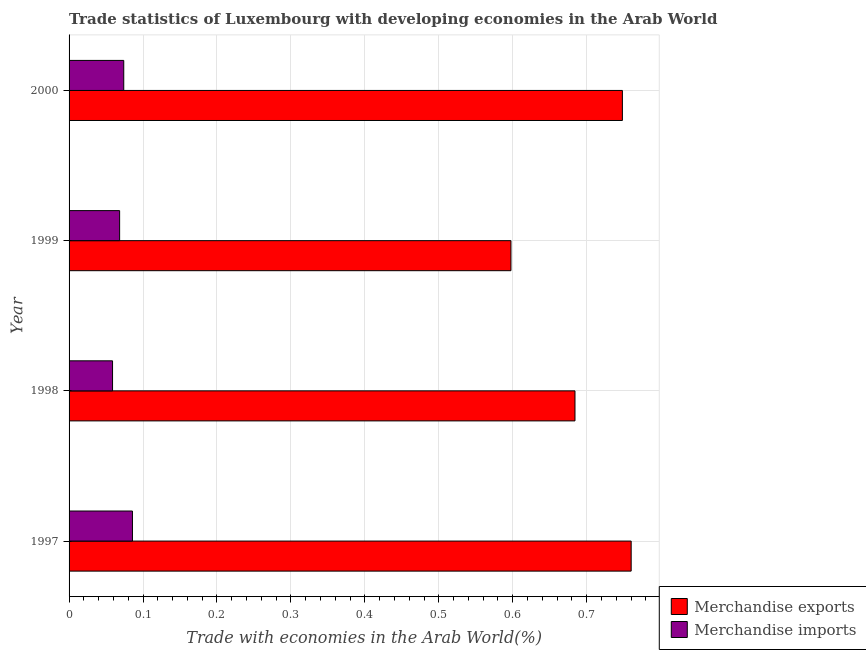How many different coloured bars are there?
Ensure brevity in your answer.  2. Are the number of bars on each tick of the Y-axis equal?
Your response must be concise. Yes. How many bars are there on the 3rd tick from the top?
Offer a terse response. 2. What is the label of the 4th group of bars from the top?
Make the answer very short. 1997. What is the merchandise exports in 1998?
Keep it short and to the point. 0.68. Across all years, what is the maximum merchandise exports?
Make the answer very short. 0.76. Across all years, what is the minimum merchandise exports?
Your answer should be compact. 0.6. In which year was the merchandise imports maximum?
Your answer should be compact. 1997. What is the total merchandise imports in the graph?
Offer a very short reply. 0.29. What is the difference between the merchandise imports in 1997 and that in 2000?
Offer a very short reply. 0.01. What is the difference between the merchandise imports in 1998 and the merchandise exports in 2000?
Offer a very short reply. -0.69. What is the average merchandise exports per year?
Your answer should be very brief. 0.7. In the year 2000, what is the difference between the merchandise exports and merchandise imports?
Ensure brevity in your answer.  0.67. What is the ratio of the merchandise imports in 1999 to that in 2000?
Keep it short and to the point. 0.92. Is the difference between the merchandise exports in 1997 and 1999 greater than the difference between the merchandise imports in 1997 and 1999?
Provide a short and direct response. Yes. What is the difference between the highest and the second highest merchandise imports?
Provide a short and direct response. 0.01. In how many years, is the merchandise exports greater than the average merchandise exports taken over all years?
Give a very brief answer. 2. Is the sum of the merchandise exports in 1998 and 2000 greater than the maximum merchandise imports across all years?
Your answer should be compact. Yes. How many bars are there?
Ensure brevity in your answer.  8. How many years are there in the graph?
Keep it short and to the point. 4. What is the difference between two consecutive major ticks on the X-axis?
Your answer should be very brief. 0.1. Does the graph contain any zero values?
Ensure brevity in your answer.  No. Does the graph contain grids?
Make the answer very short. Yes. How many legend labels are there?
Your answer should be very brief. 2. What is the title of the graph?
Your answer should be very brief. Trade statistics of Luxembourg with developing economies in the Arab World. Does "US$" appear as one of the legend labels in the graph?
Provide a succinct answer. No. What is the label or title of the X-axis?
Offer a terse response. Trade with economies in the Arab World(%). What is the Trade with economies in the Arab World(%) of Merchandise exports in 1997?
Give a very brief answer. 0.76. What is the Trade with economies in the Arab World(%) of Merchandise imports in 1997?
Offer a terse response. 0.09. What is the Trade with economies in the Arab World(%) of Merchandise exports in 1998?
Give a very brief answer. 0.68. What is the Trade with economies in the Arab World(%) in Merchandise imports in 1998?
Offer a very short reply. 0.06. What is the Trade with economies in the Arab World(%) in Merchandise exports in 1999?
Offer a very short reply. 0.6. What is the Trade with economies in the Arab World(%) in Merchandise imports in 1999?
Your answer should be compact. 0.07. What is the Trade with economies in the Arab World(%) of Merchandise exports in 2000?
Provide a short and direct response. 0.75. What is the Trade with economies in the Arab World(%) of Merchandise imports in 2000?
Your response must be concise. 0.07. Across all years, what is the maximum Trade with economies in the Arab World(%) of Merchandise exports?
Provide a succinct answer. 0.76. Across all years, what is the maximum Trade with economies in the Arab World(%) in Merchandise imports?
Your response must be concise. 0.09. Across all years, what is the minimum Trade with economies in the Arab World(%) in Merchandise exports?
Provide a short and direct response. 0.6. Across all years, what is the minimum Trade with economies in the Arab World(%) in Merchandise imports?
Offer a terse response. 0.06. What is the total Trade with economies in the Arab World(%) in Merchandise exports in the graph?
Keep it short and to the point. 2.79. What is the total Trade with economies in the Arab World(%) of Merchandise imports in the graph?
Make the answer very short. 0.29. What is the difference between the Trade with economies in the Arab World(%) in Merchandise exports in 1997 and that in 1998?
Ensure brevity in your answer.  0.08. What is the difference between the Trade with economies in the Arab World(%) in Merchandise imports in 1997 and that in 1998?
Your answer should be very brief. 0.03. What is the difference between the Trade with economies in the Arab World(%) of Merchandise exports in 1997 and that in 1999?
Keep it short and to the point. 0.16. What is the difference between the Trade with economies in the Arab World(%) in Merchandise imports in 1997 and that in 1999?
Ensure brevity in your answer.  0.02. What is the difference between the Trade with economies in the Arab World(%) of Merchandise exports in 1997 and that in 2000?
Your response must be concise. 0.01. What is the difference between the Trade with economies in the Arab World(%) in Merchandise imports in 1997 and that in 2000?
Ensure brevity in your answer.  0.01. What is the difference between the Trade with economies in the Arab World(%) in Merchandise exports in 1998 and that in 1999?
Offer a very short reply. 0.09. What is the difference between the Trade with economies in the Arab World(%) in Merchandise imports in 1998 and that in 1999?
Provide a short and direct response. -0.01. What is the difference between the Trade with economies in the Arab World(%) in Merchandise exports in 1998 and that in 2000?
Give a very brief answer. -0.06. What is the difference between the Trade with economies in the Arab World(%) in Merchandise imports in 1998 and that in 2000?
Offer a terse response. -0.02. What is the difference between the Trade with economies in the Arab World(%) in Merchandise exports in 1999 and that in 2000?
Your response must be concise. -0.15. What is the difference between the Trade with economies in the Arab World(%) of Merchandise imports in 1999 and that in 2000?
Ensure brevity in your answer.  -0.01. What is the difference between the Trade with economies in the Arab World(%) of Merchandise exports in 1997 and the Trade with economies in the Arab World(%) of Merchandise imports in 1998?
Your response must be concise. 0.7. What is the difference between the Trade with economies in the Arab World(%) of Merchandise exports in 1997 and the Trade with economies in the Arab World(%) of Merchandise imports in 1999?
Your answer should be very brief. 0.69. What is the difference between the Trade with economies in the Arab World(%) in Merchandise exports in 1997 and the Trade with economies in the Arab World(%) in Merchandise imports in 2000?
Your response must be concise. 0.69. What is the difference between the Trade with economies in the Arab World(%) of Merchandise exports in 1998 and the Trade with economies in the Arab World(%) of Merchandise imports in 1999?
Ensure brevity in your answer.  0.62. What is the difference between the Trade with economies in the Arab World(%) in Merchandise exports in 1998 and the Trade with economies in the Arab World(%) in Merchandise imports in 2000?
Offer a terse response. 0.61. What is the difference between the Trade with economies in the Arab World(%) of Merchandise exports in 1999 and the Trade with economies in the Arab World(%) of Merchandise imports in 2000?
Ensure brevity in your answer.  0.52. What is the average Trade with economies in the Arab World(%) of Merchandise exports per year?
Your answer should be very brief. 0.7. What is the average Trade with economies in the Arab World(%) in Merchandise imports per year?
Your answer should be very brief. 0.07. In the year 1997, what is the difference between the Trade with economies in the Arab World(%) of Merchandise exports and Trade with economies in the Arab World(%) of Merchandise imports?
Make the answer very short. 0.67. In the year 1998, what is the difference between the Trade with economies in the Arab World(%) in Merchandise exports and Trade with economies in the Arab World(%) in Merchandise imports?
Your response must be concise. 0.63. In the year 1999, what is the difference between the Trade with economies in the Arab World(%) of Merchandise exports and Trade with economies in the Arab World(%) of Merchandise imports?
Provide a short and direct response. 0.53. In the year 2000, what is the difference between the Trade with economies in the Arab World(%) of Merchandise exports and Trade with economies in the Arab World(%) of Merchandise imports?
Keep it short and to the point. 0.67. What is the ratio of the Trade with economies in the Arab World(%) in Merchandise exports in 1997 to that in 1998?
Your answer should be very brief. 1.11. What is the ratio of the Trade with economies in the Arab World(%) in Merchandise imports in 1997 to that in 1998?
Your response must be concise. 1.46. What is the ratio of the Trade with economies in the Arab World(%) of Merchandise exports in 1997 to that in 1999?
Your answer should be very brief. 1.27. What is the ratio of the Trade with economies in the Arab World(%) in Merchandise imports in 1997 to that in 1999?
Keep it short and to the point. 1.25. What is the ratio of the Trade with economies in the Arab World(%) of Merchandise exports in 1997 to that in 2000?
Provide a short and direct response. 1.02. What is the ratio of the Trade with economies in the Arab World(%) of Merchandise imports in 1997 to that in 2000?
Ensure brevity in your answer.  1.16. What is the ratio of the Trade with economies in the Arab World(%) of Merchandise exports in 1998 to that in 1999?
Provide a succinct answer. 1.14. What is the ratio of the Trade with economies in the Arab World(%) of Merchandise imports in 1998 to that in 1999?
Make the answer very short. 0.86. What is the ratio of the Trade with economies in the Arab World(%) of Merchandise exports in 1998 to that in 2000?
Provide a short and direct response. 0.91. What is the ratio of the Trade with economies in the Arab World(%) in Merchandise imports in 1998 to that in 2000?
Keep it short and to the point. 0.8. What is the ratio of the Trade with economies in the Arab World(%) of Merchandise exports in 1999 to that in 2000?
Offer a terse response. 0.8. What is the ratio of the Trade with economies in the Arab World(%) in Merchandise imports in 1999 to that in 2000?
Your response must be concise. 0.92. What is the difference between the highest and the second highest Trade with economies in the Arab World(%) of Merchandise exports?
Make the answer very short. 0.01. What is the difference between the highest and the second highest Trade with economies in the Arab World(%) of Merchandise imports?
Offer a terse response. 0.01. What is the difference between the highest and the lowest Trade with economies in the Arab World(%) in Merchandise exports?
Make the answer very short. 0.16. What is the difference between the highest and the lowest Trade with economies in the Arab World(%) of Merchandise imports?
Give a very brief answer. 0.03. 